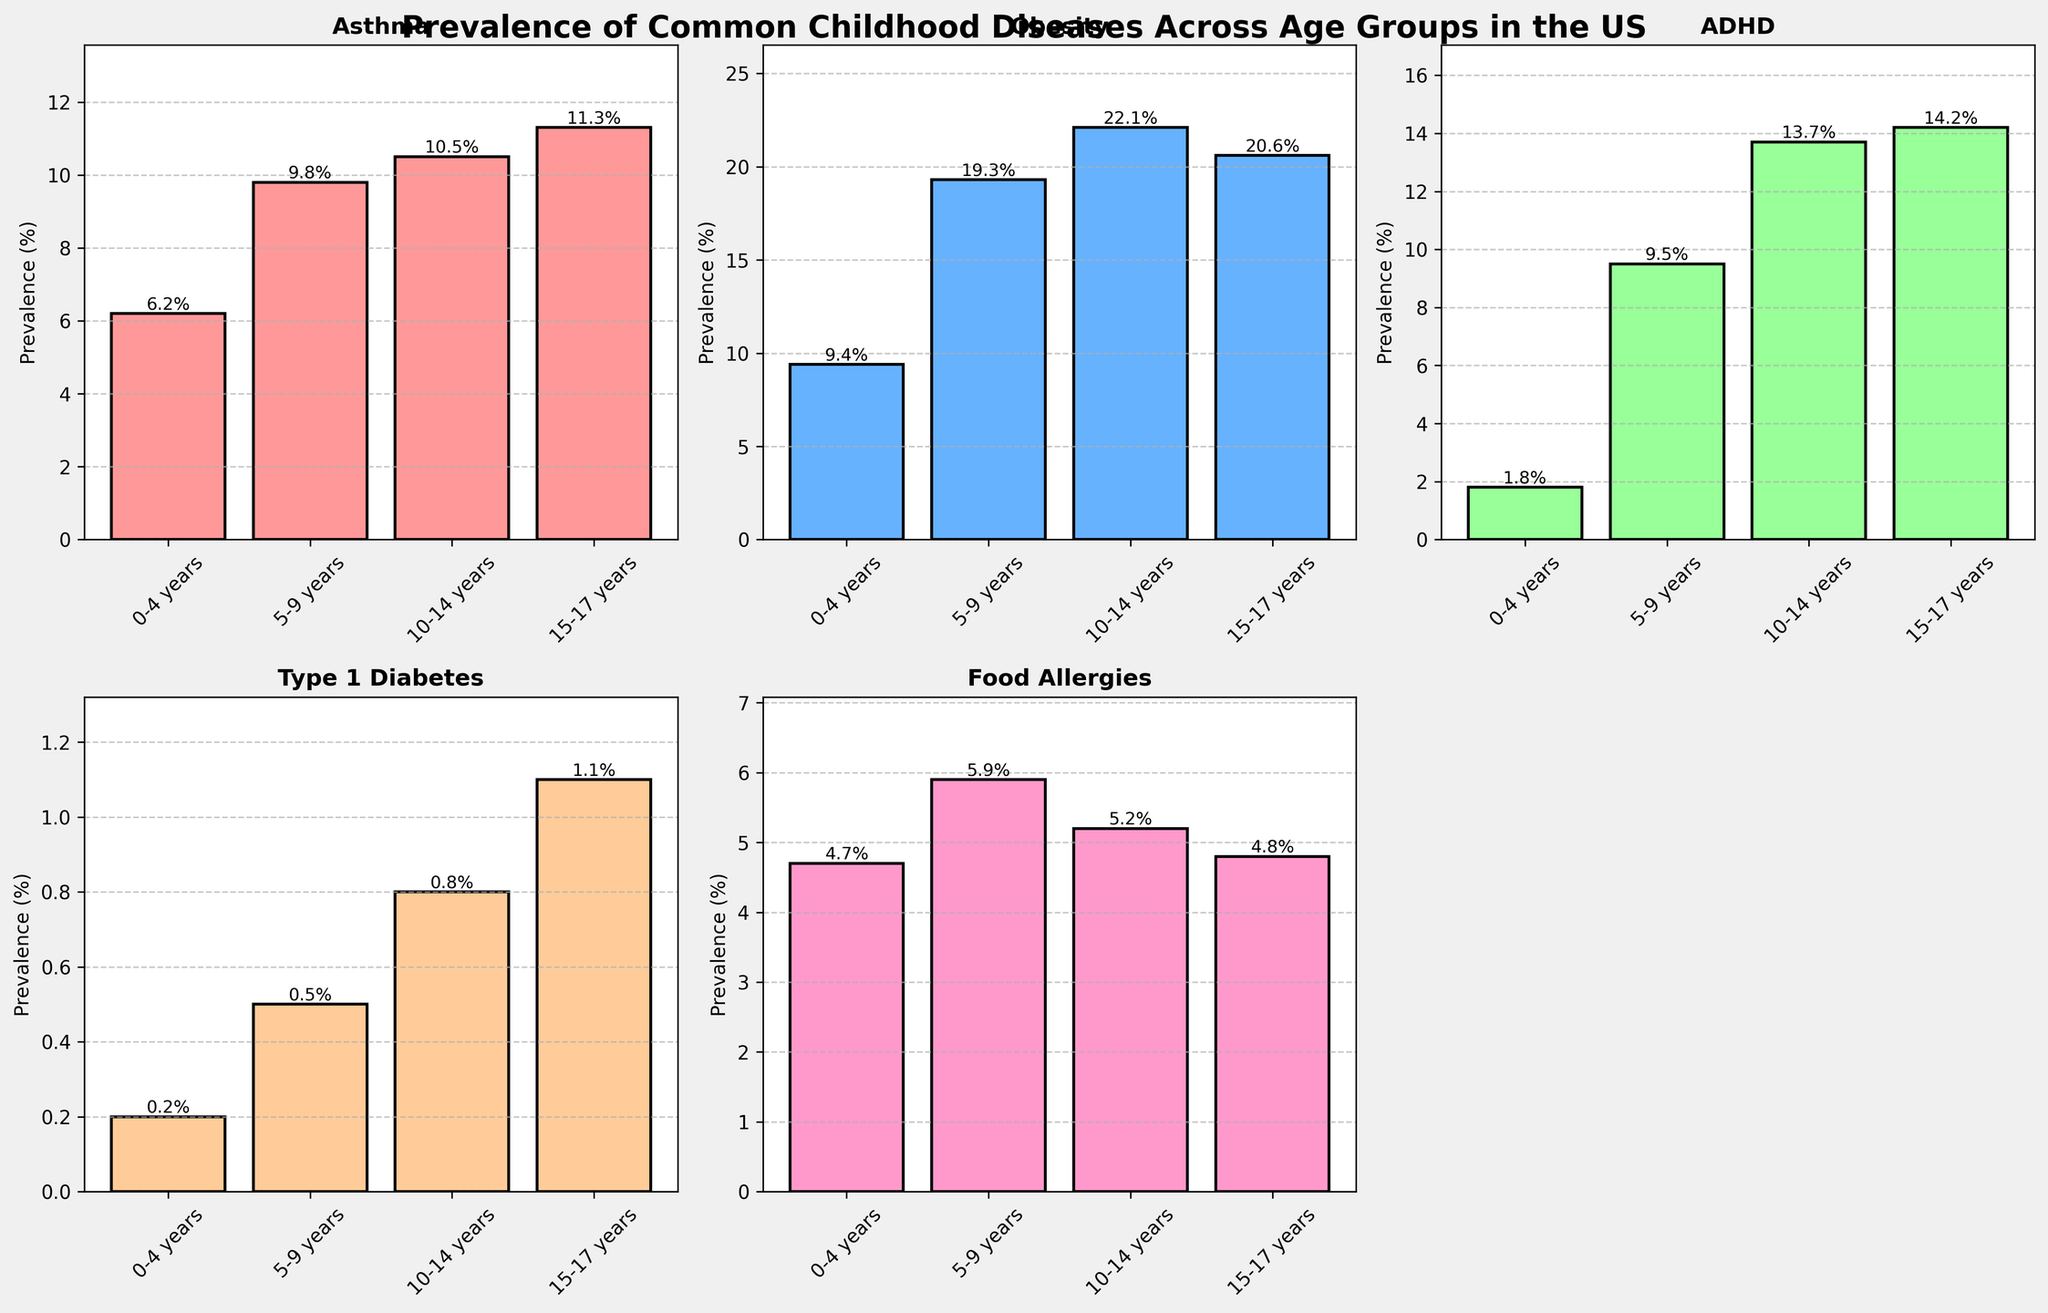What's the title of the figure? The title is found at the top of the figure, usually in a larger and bold font. Here, it's clearly visible at the top.
Answer: Prevalence of Common Childhood Diseases Across Age Groups in the US How many age groups are presented in the figure? Each subplot shows the same categories on the x-axis, which can be counted. There are four age groups listed: 0-4 years, 5-9 years, 10-14 years, and 15-17 years.
Answer: 4 Which disease has the highest prevalence in the 10-14 years age group? Look at the bar heights for the 10-14 years age group across all subplots. The tallest bar among them corresponds to the disease with the highest prevalence.
Answer: Obesity What is the difference in ADHD prevalence between the 0-4 years and 15-17 years age groups? Subtract the prevalence percentage for the 0-4 years group from the 15-17 years group in the ADHD subplot.
Answer: 12.4% Between which age groups does Type 1 Diabetes show a significant increase? Compare the heights of the bars corresponding to Type 1 Diabetes across all age groups. Identify where the most noticeable increase occurs.
Answer: Between 10-14 years and 15-17 years Which age group has the highest prevalence of Food Allergies? Look at the bars in the Food Allergies subplot and identify the age group with the tallest bar.
Answer: 5-9 years Is the prevalence of Asthma increasing or decreasing with age? Observe the bars in the Asthma subplot to see whether their heights generally increase or decrease from the youngest to oldest age group.
Answer: Increasing What's the average prevalence of Obesity across all age groups? Sum the prevalence percentages for Obesity across all age groups and divide by the number of age groups to find the average.
Answer: (9.4 + 19.3 + 22.1 + 20.6) / 4 = 17.85% Which disease shows the least variation in prevalence across different age groups? Compare the range of bar heights for each disease subplot. The disease with the least difference between the tallest and shortest bars shows the least variation.
Answer: Food Allergies 